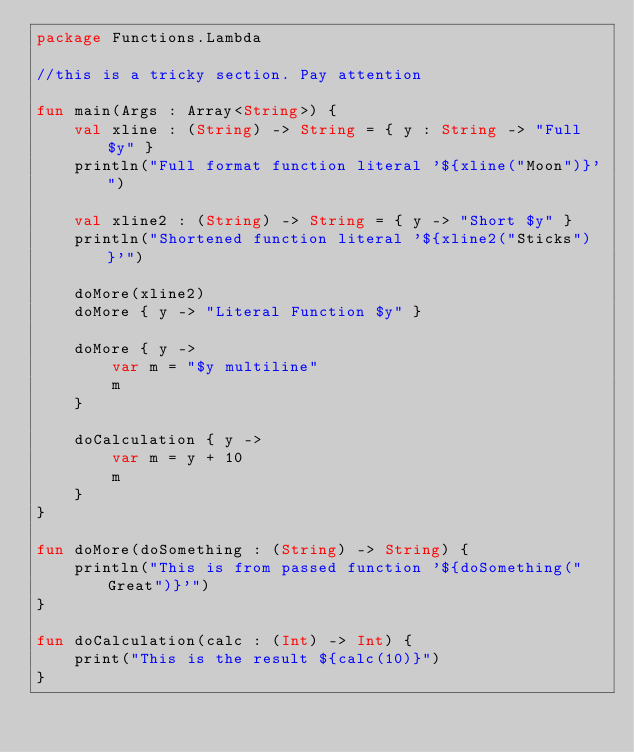<code> <loc_0><loc_0><loc_500><loc_500><_Kotlin_>package Functions.Lambda

//this is a tricky section. Pay attention

fun main(Args : Array<String>) {
    val xline : (String) -> String = { y : String -> "Full $y" }
    println("Full format function literal '${xline("Moon")}'")

    val xline2 : (String) -> String = { y -> "Short $y" }
    println("Shortened function literal '${xline2("Sticks")}'")

    doMore(xline2)
    doMore { y -> "Literal Function $y" }

    doMore { y ->
        var m = "$y multiline"
        m
    }

    doCalculation { y ->
        var m = y + 10
        m
    }
}

fun doMore(doSomething : (String) -> String) {
    println("This is from passed function '${doSomething("Great")}'")
}

fun doCalculation(calc : (Int) -> Int) {
    print("This is the result ${calc(10)}")
}
</code> 